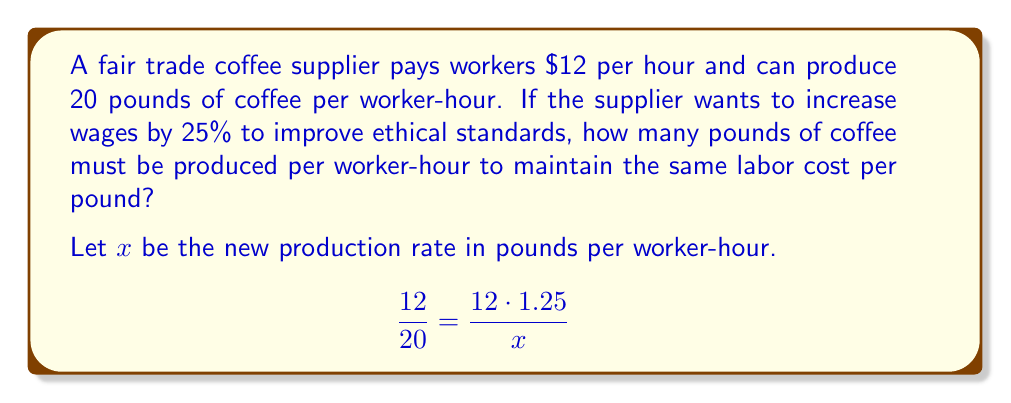Could you help me with this problem? 1. Set up the equation:
   The current labor cost per pound is $\frac{12}{20}$ (wage divided by production rate).
   The new labor cost per pound should equal this, with the new wage ($12 \cdot 1.25$) and new production rate ($x$).

2. Solve for $x$:
   $$\frac{12}{20} = \frac{12 \cdot 1.25}{x}$$
   $$\frac{12}{20} = \frac{15}{x}$$

3. Cross multiply:
   $$12x = 20 \cdot 15$$
   $$12x = 300$$

4. Divide both sides by 12:
   $$x = \frac{300}{12} = 25$$

5. Interpret the result:
   The new production rate needs to be 25 pounds per worker-hour to maintain the same labor cost per pound while increasing wages by 25%.
Answer: 25 pounds per worker-hour 